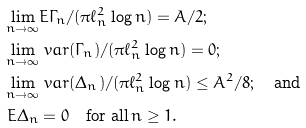<formula> <loc_0><loc_0><loc_500><loc_500>\lim _ { n \rightarrow \infty } & E \Gamma _ { n } / ( \pi \ell _ { n } ^ { 2 } \log n ) = A / 2 ; \\ \lim _ { n \rightarrow \infty } & \ v a r ( \Gamma _ { n } ) / ( \pi \ell _ { n } ^ { 2 } \log n ) = 0 ; \\ \lim _ { n \rightarrow \infty } & \ v a r ( \Delta _ { n } ) / ( \pi \ell _ { n } ^ { 2 } \log n ) \leq A ^ { 2 } / 8 ; \quad \text {and} \\ E \Delta _ { n } & = 0 \quad \text {for all} \, n \geq 1 .</formula> 